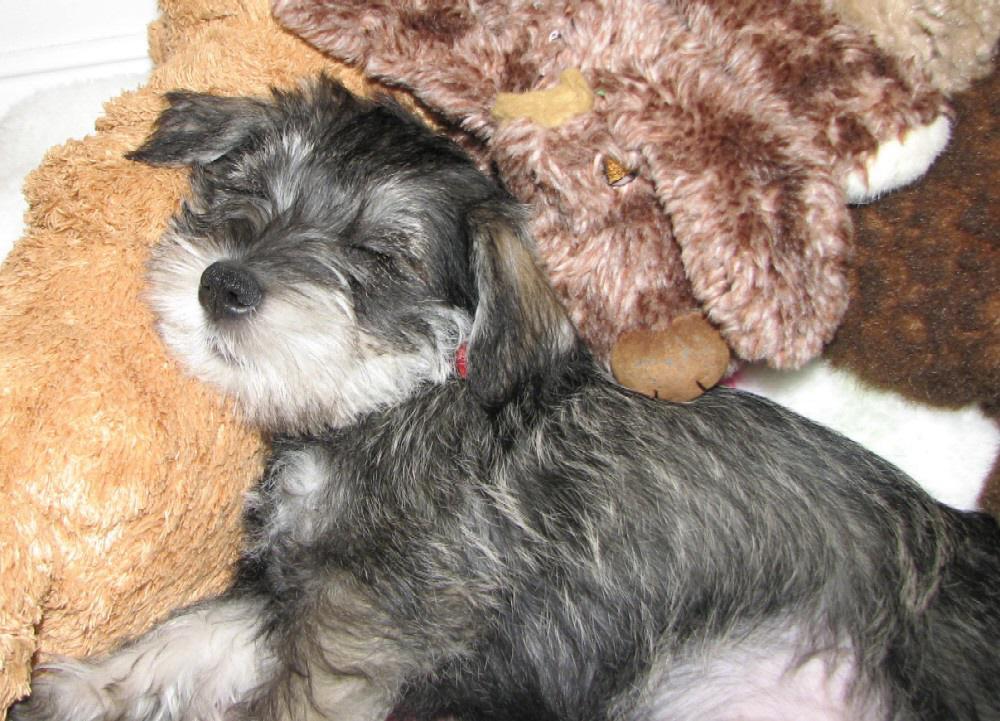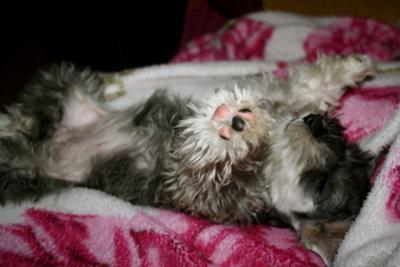The first image is the image on the left, the second image is the image on the right. Examine the images to the left and right. Is the description "There are more dogs in the image on the right." accurate? Answer yes or no. No. 